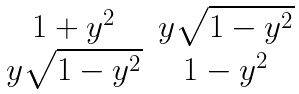Convert formula to latex. <formula><loc_0><loc_0><loc_500><loc_500>\begin{matrix} 1 + y ^ { 2 } & y \sqrt { 1 - y ^ { 2 } } \\ y \sqrt { 1 - y ^ { 2 } } & 1 - y ^ { 2 } \end{matrix}</formula> 